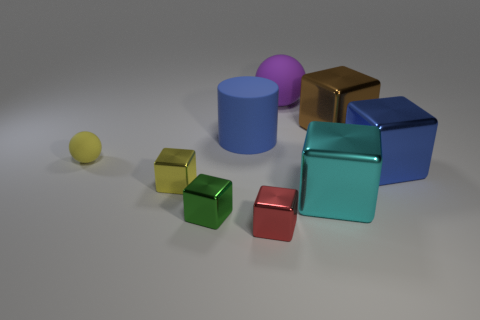What is the shape of the thing that is the same color as the cylinder?
Give a very brief answer. Cube. What number of other things are the same size as the blue cylinder?
Offer a very short reply. 4. There is a blue thing to the right of the large cyan shiny block; does it have the same shape as the purple thing?
Your answer should be very brief. No. Is the number of balls that are to the right of the small red block greater than the number of tiny brown metal cubes?
Your answer should be compact. Yes. The object that is both behind the large cylinder and right of the big purple rubber object is made of what material?
Your answer should be compact. Metal. Are there any other things that have the same shape as the large blue rubber thing?
Your answer should be very brief. No. How many objects are left of the small red metal thing and behind the big cyan shiny cube?
Offer a very short reply. 3. What material is the small yellow sphere?
Keep it short and to the point. Rubber. Are there the same number of green cubes that are in front of the cyan shiny thing and big blue metallic things?
Offer a terse response. Yes. What number of tiny purple metal objects are the same shape as the big brown metal thing?
Keep it short and to the point. 0. 